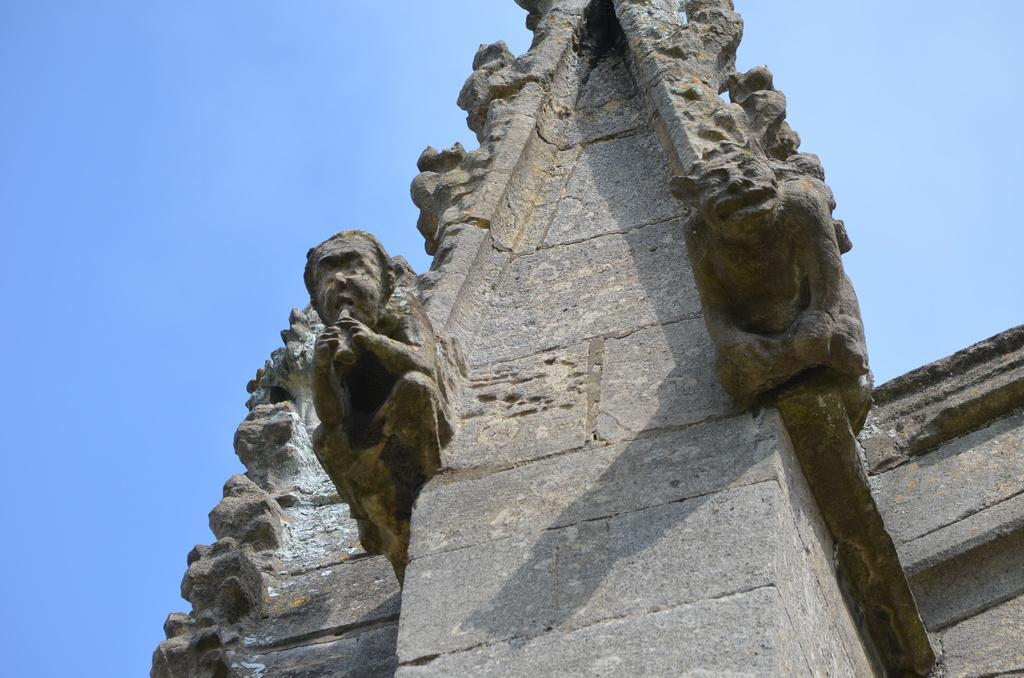Could you give a brief overview of what you see in this image? In this picture we can see sculptures and a wall. In the background there is sky. 